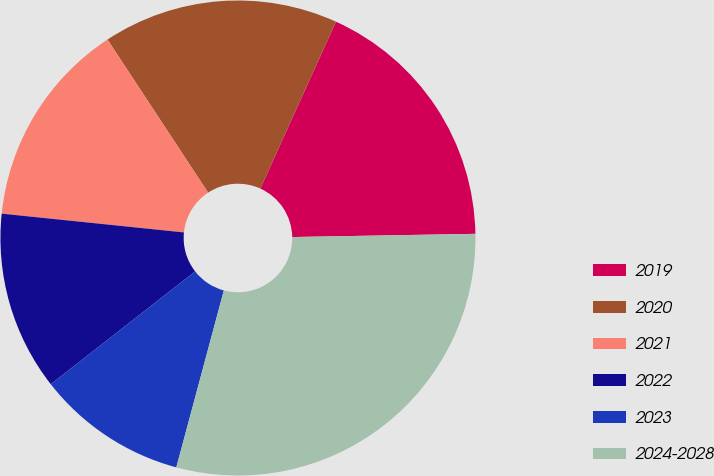Convert chart. <chart><loc_0><loc_0><loc_500><loc_500><pie_chart><fcel>2019<fcel>2020<fcel>2021<fcel>2022<fcel>2023<fcel>2024-2028<nl><fcel>17.95%<fcel>16.03%<fcel>14.11%<fcel>12.19%<fcel>10.27%<fcel>29.46%<nl></chart> 